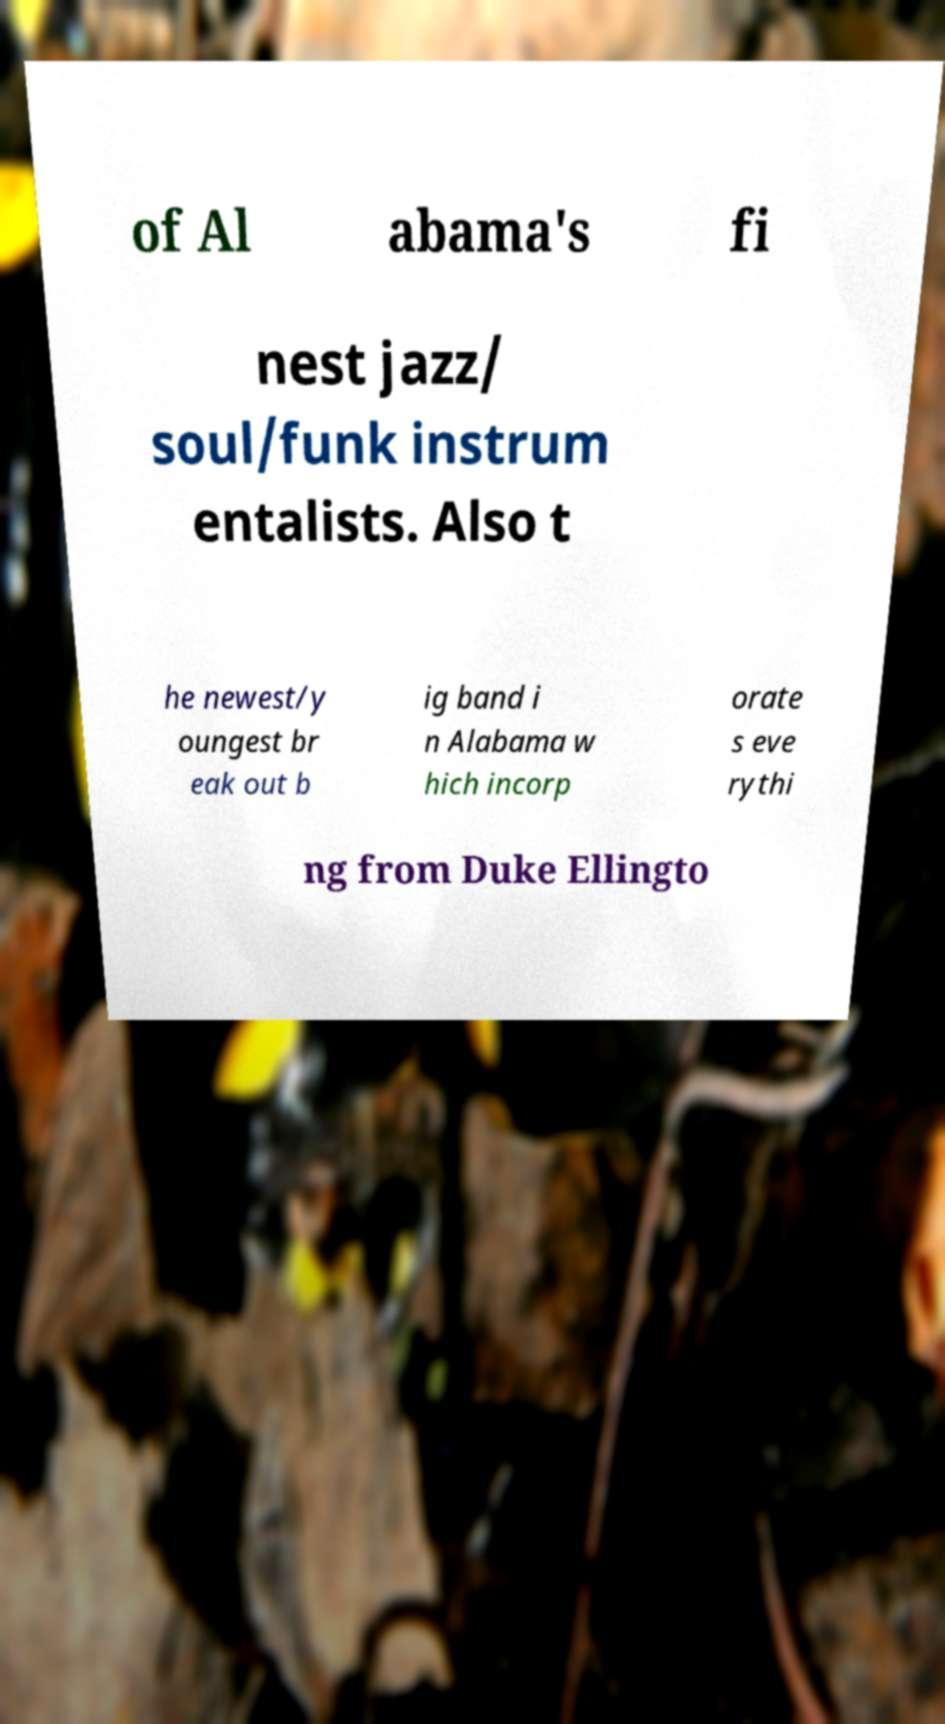Can you accurately transcribe the text from the provided image for me? of Al abama's fi nest jazz/ soul/funk instrum entalists. Also t he newest/y oungest br eak out b ig band i n Alabama w hich incorp orate s eve rythi ng from Duke Ellingto 